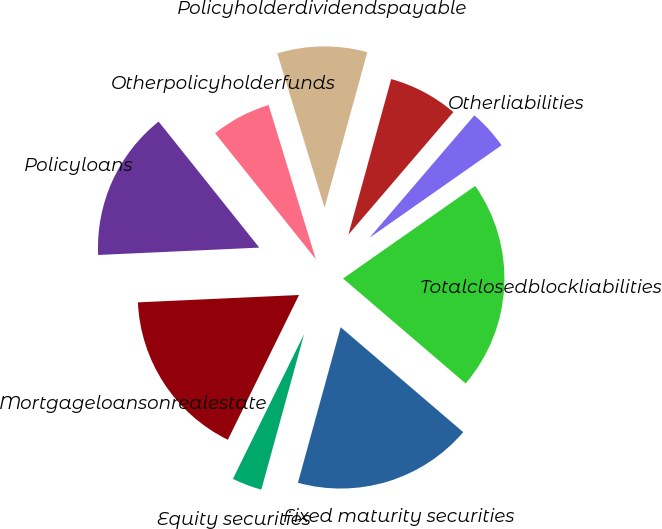Convert chart to OTSL. <chart><loc_0><loc_0><loc_500><loc_500><pie_chart><fcel>Otherpolicyholderfunds<fcel>Policyholderdividendspayable<fcel>Unnamed: 2<fcel>Otherliabilities<fcel>Totalclosedblockliabilities<fcel>Fixed maturity securities<fcel>Equity securities<fcel>Mortgageloansonrealestate<fcel>Policyloans<nl><fcel>6.0%<fcel>9.0%<fcel>7.0%<fcel>4.0%<fcel>21.0%<fcel>18.0%<fcel>3.0%<fcel>17.0%<fcel>15.0%<nl></chart> 